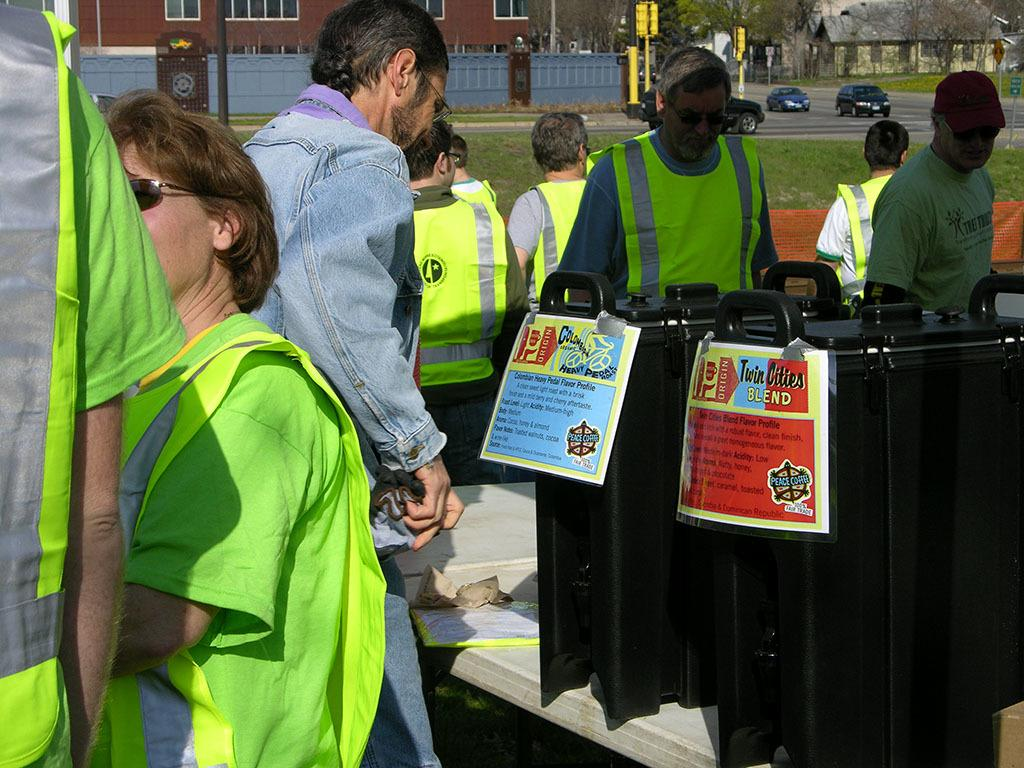<image>
Offer a succinct explanation of the picture presented. several people wearing safety vest and man looking at coffee selections columbian heavy pedal roast and twin cities blend 